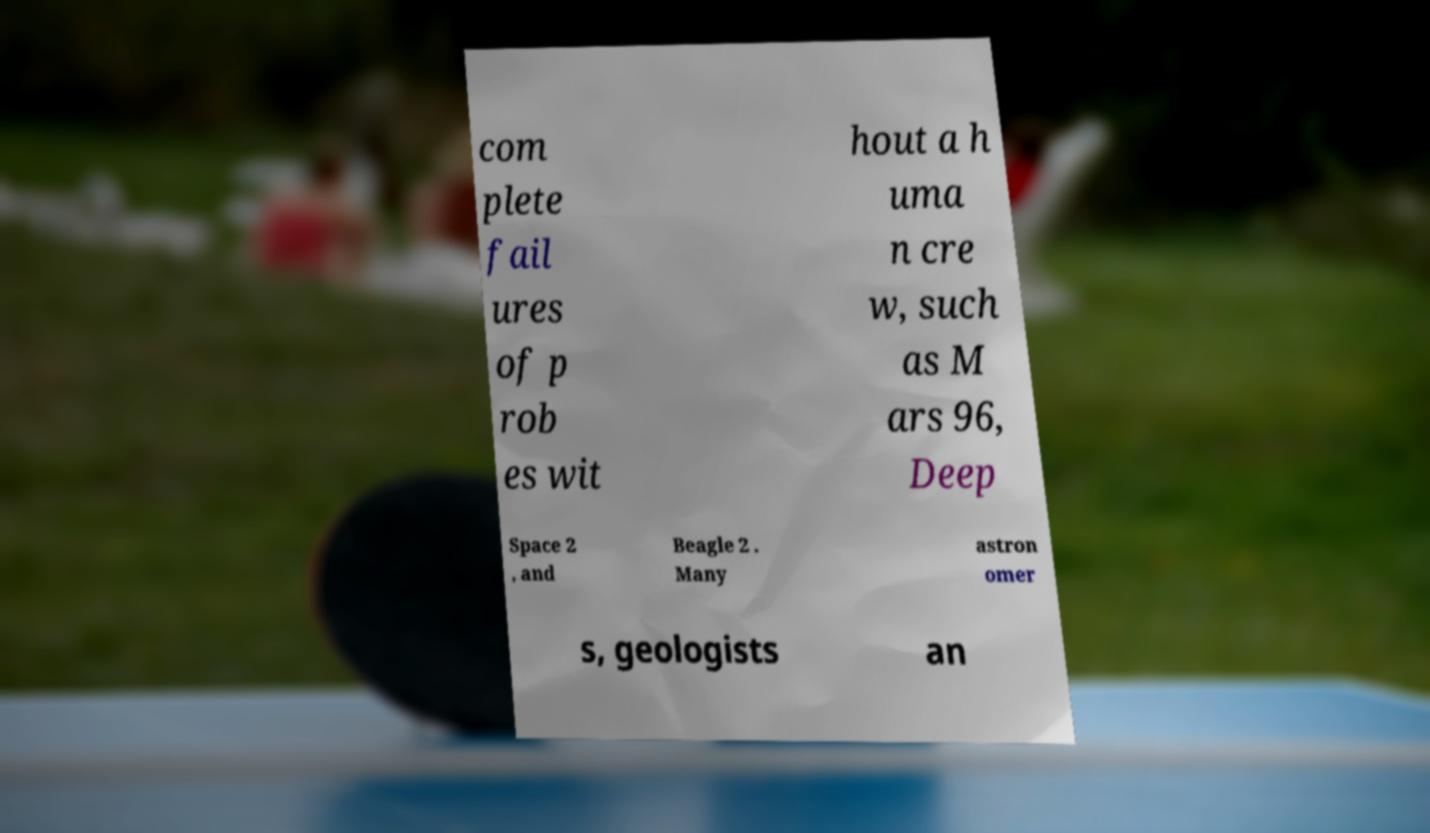Please identify and transcribe the text found in this image. com plete fail ures of p rob es wit hout a h uma n cre w, such as M ars 96, Deep Space 2 , and Beagle 2 . Many astron omer s, geologists an 